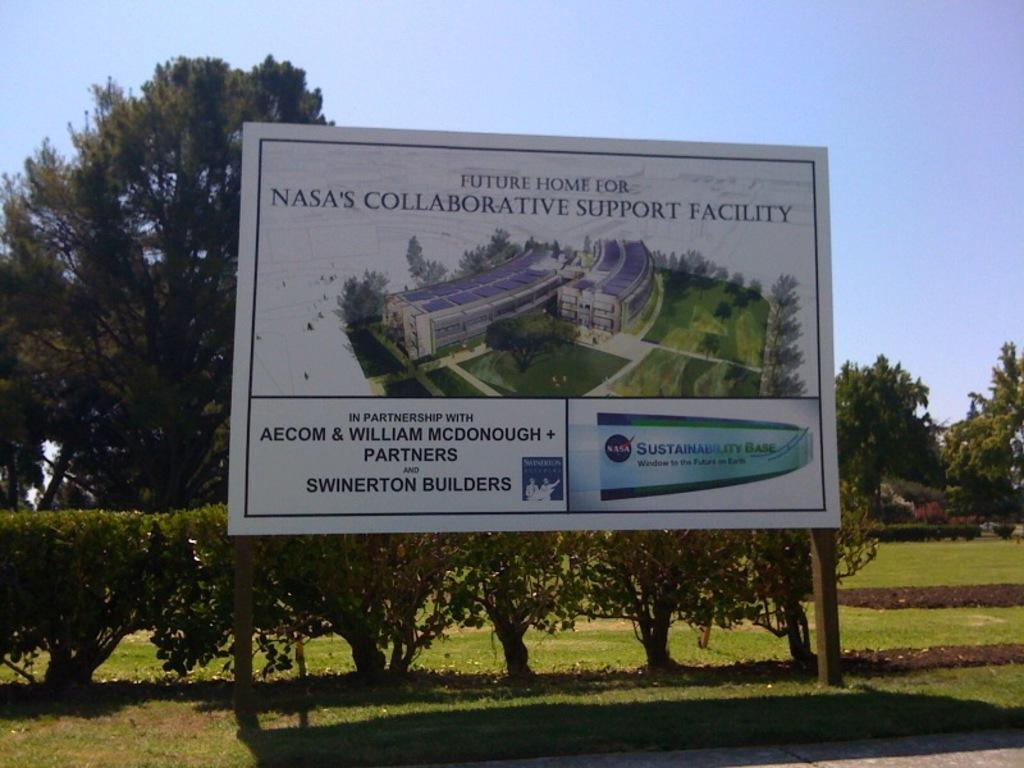<image>
Relay a brief, clear account of the picture shown. A sign for the future home for the NASA's collaborative support facility. 